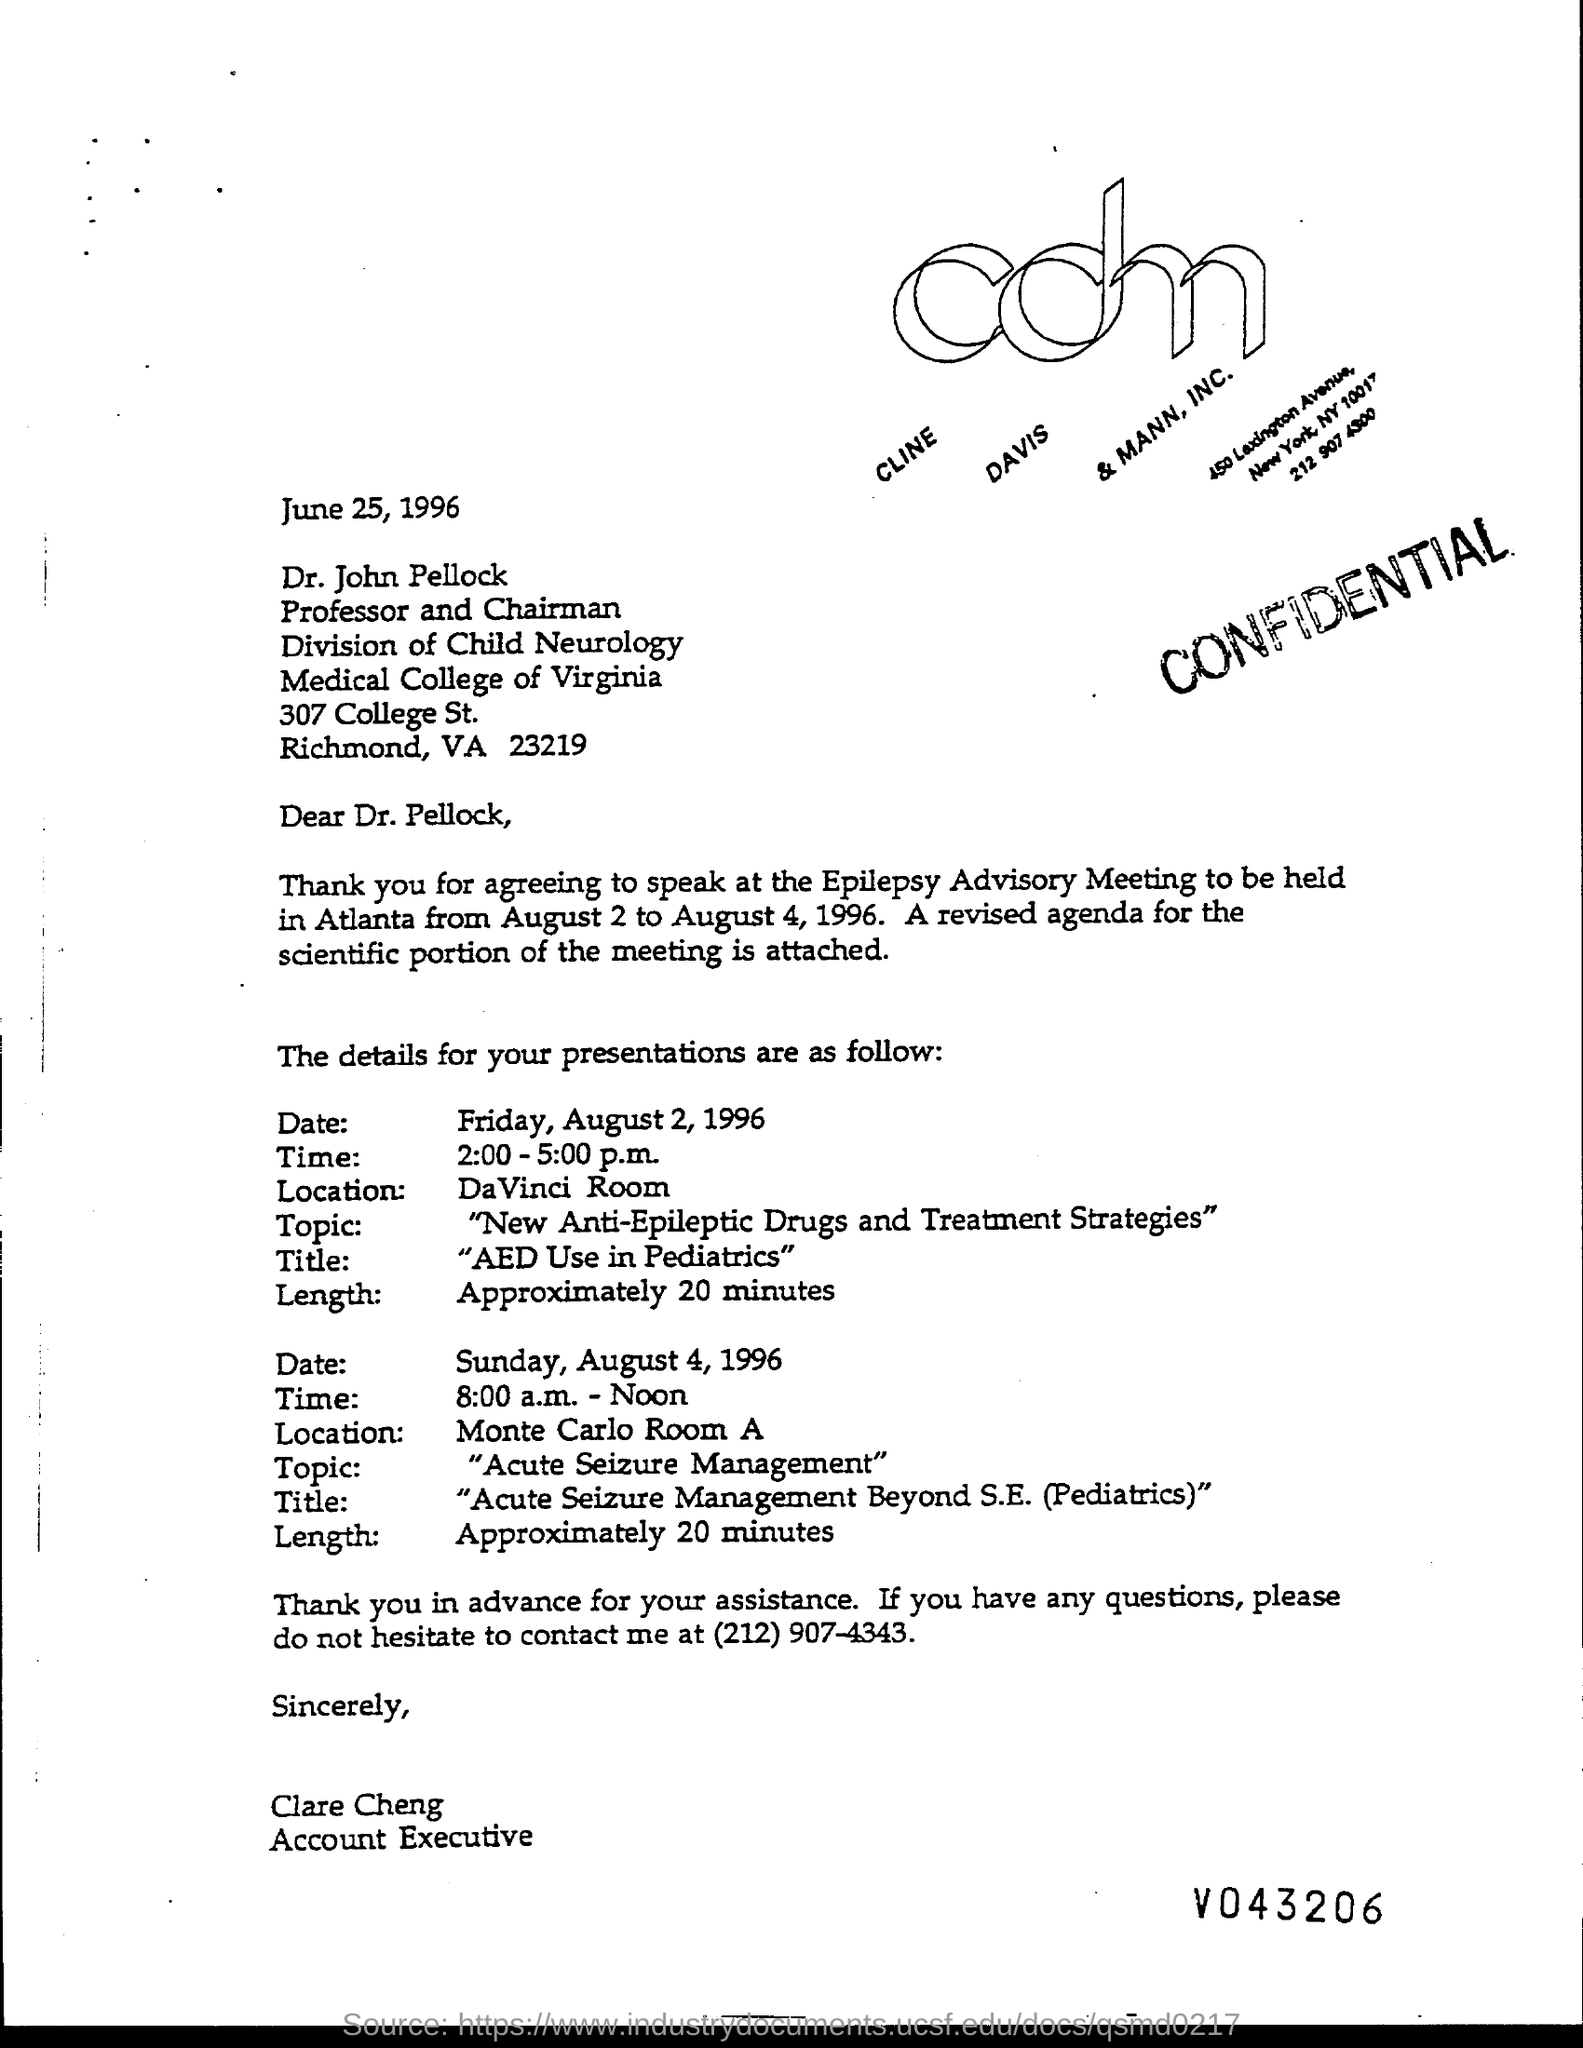Outline some significant characteristics in this image. The letter is addressed to Dr. John Pellock. The title of the presentation on Sunday, August 4, 1996, was "ACUTE SEIZURE MANAGEMENT BEYOND S.E.(PEDIATRICS)". The security level of the document is confidential. On Sunday, August 4, 1996, the presentation time was 8:00 a.m. to 12:00 p.m. On Friday, August 2, 1996, the presentation time was from 2:00 PM to 5:00 PM. 